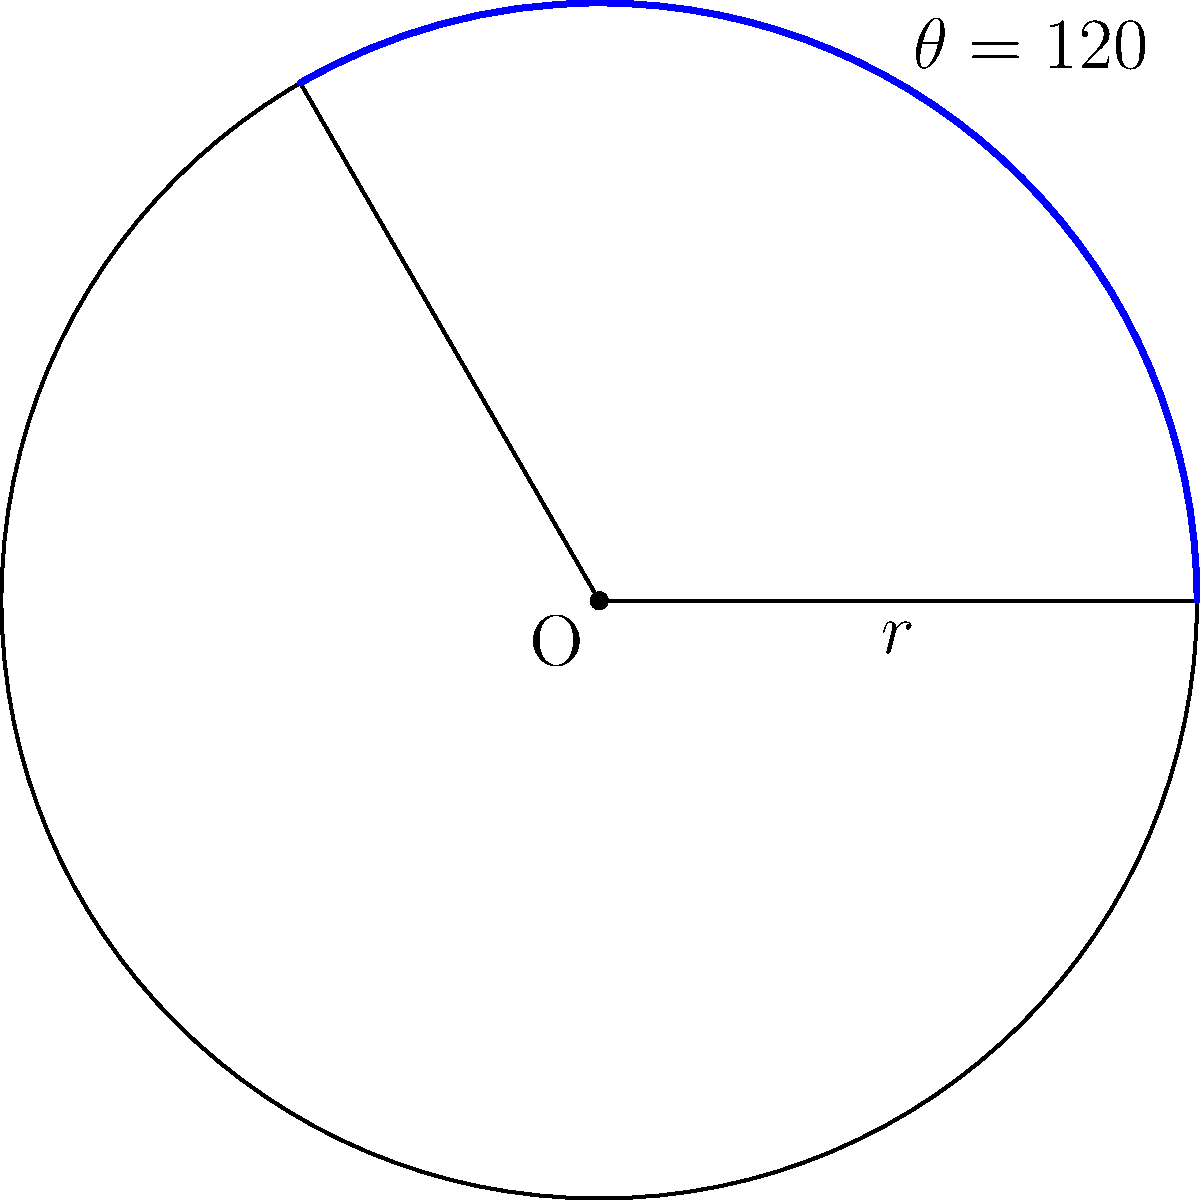In a workflow automation system, you're designing a circular progress indicator. The indicator's arc length represents the completion percentage. Given a circle with radius $r = 5$ cm and a central angle $\theta = 120°$, calculate the length of the arc that represents the progress. How would you integrate this calculation into your automation workflow? To calculate the length of an arc given the central angle and radius of a circle, we can follow these steps:

1. Recall the formula for arc length: $s = r\theta$
   Where $s$ is the arc length, $r$ is the radius, and $\theta$ is the central angle in radians.

2. We're given the angle in degrees, so we need to convert it to radians:
   $\theta_{rad} = \theta_{deg} \cdot \frac{\pi}{180°}$
   $\theta_{rad} = 120° \cdot \frac{\pi}{180°} = \frac{2\pi}{3}$ radians

3. Now we can substitute the values into the arc length formula:
   $s = r\theta$
   $s = 5 \cdot \frac{2\pi}{3}$
   $s = \frac{10\pi}{3}$ cm

4. To integrate this into a workflow automation system, you could create a function that takes the radius and angle as inputs and returns the arc length. This function could be called whenever the progress updates, allowing for dynamic calculation of the arc length based on the current progress percentage.
Answer: $\frac{10\pi}{3}$ cm 